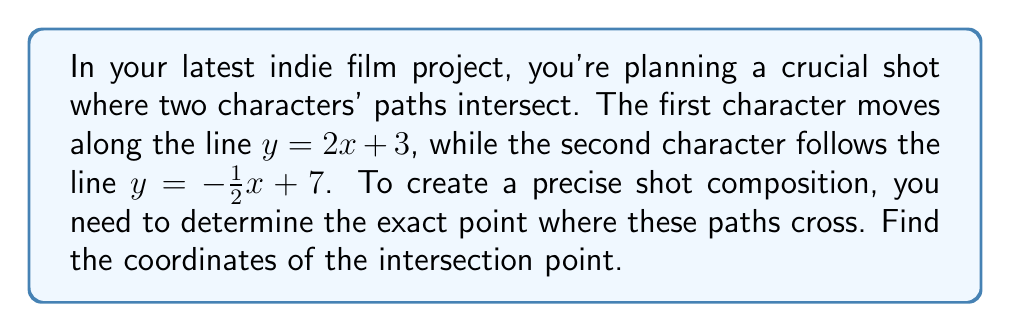Can you answer this question? To find the intersection point of two lines, we need to solve the system of equations formed by the two line equations:

$$\begin{cases}
y = 2x + 3 \\
y = -\frac{1}{2}x + 7
\end{cases}$$

Step 1: Set the two equations equal to each other since they represent the same y-coordinate at the intersection point.

$2x + 3 = -\frac{1}{2}x + 7$

Step 2: Solve for x by adding $\frac{1}{2}x$ to both sides and subtracting 3 from both sides.

$2x + \frac{1}{2}x = 7 - 3$
$\frac{5}{2}x = 4$

Step 3: Divide both sides by $\frac{5}{2}$ to isolate x.

$x = \frac{4}{\frac{5}{2}} = \frac{8}{5} = 1.6$

Step 4: Substitute this x-value into either of the original equations to find y. Let's use the first equation:

$y = 2x + 3$
$y = 2(1.6) + 3$
$y = 3.2 + 3 = 6.2$

Therefore, the intersection point is (1.6, 6.2).

[asy]
import graph;
size(200);
xaxis("x");
yaxis("y");

real f(real x) {return 2x + 3;}
real g(real x) {return -0.5x + 7;}

draw(graph(f, -1, 3));
draw(graph(g, -1, 3), dashed);

dot((1.6, 6.2), red);
label("(1.6, 6.2)", (1.6, 6.2), NE, red);

label("y = 2x + 3", (2.5, 8), N);
label("y = -1/2x + 7", (-0.5, 7.5), NW);
[/asy]
Answer: The intersection point is (1.6, 6.2). 